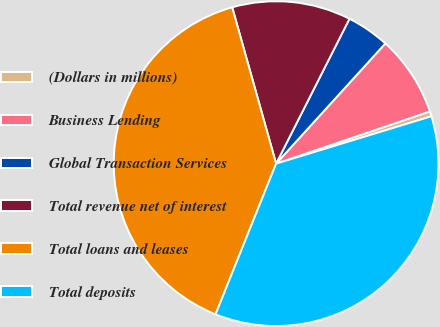Convert chart. <chart><loc_0><loc_0><loc_500><loc_500><pie_chart><fcel>(Dollars in millions)<fcel>Business Lending<fcel>Global Transaction Services<fcel>Total revenue net of interest<fcel>Total loans and leases<fcel>Total deposits<nl><fcel>0.5%<fcel>8.05%<fcel>4.28%<fcel>11.82%<fcel>39.56%<fcel>35.79%<nl></chart> 